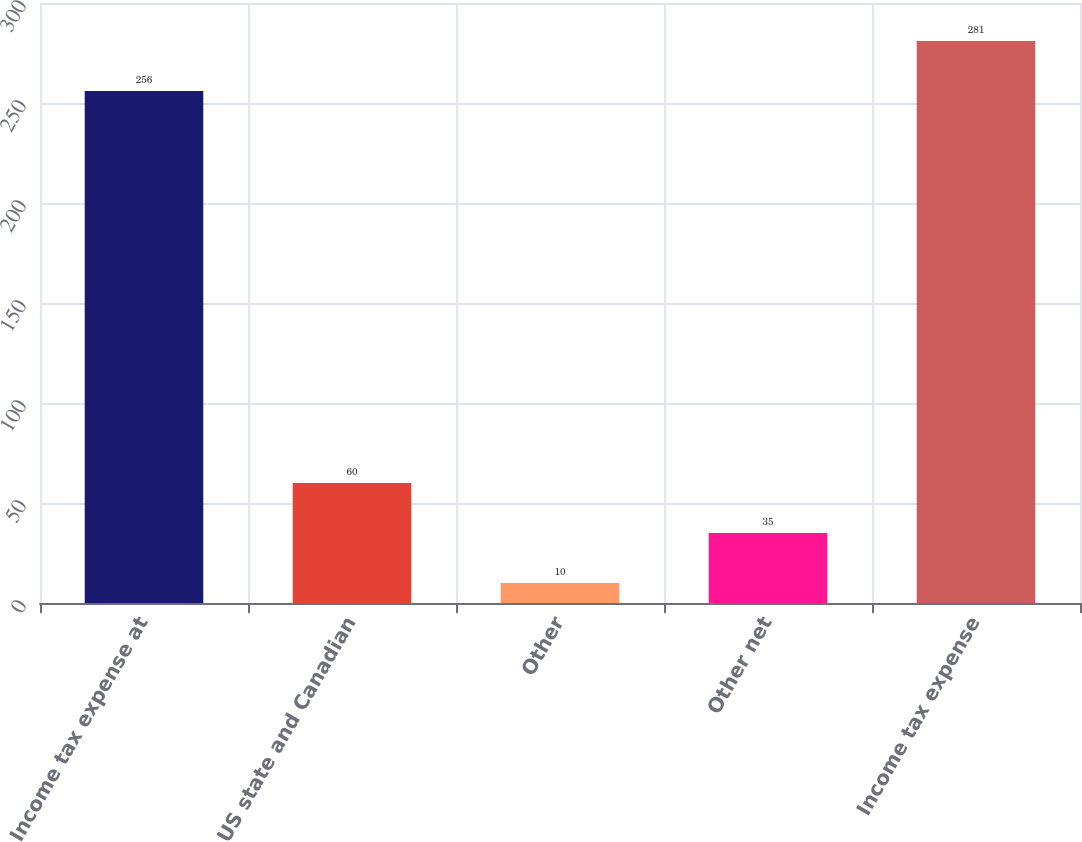<chart> <loc_0><loc_0><loc_500><loc_500><bar_chart><fcel>Income tax expense at<fcel>US state and Canadian<fcel>Other<fcel>Other net<fcel>Income tax expense<nl><fcel>256<fcel>60<fcel>10<fcel>35<fcel>281<nl></chart> 